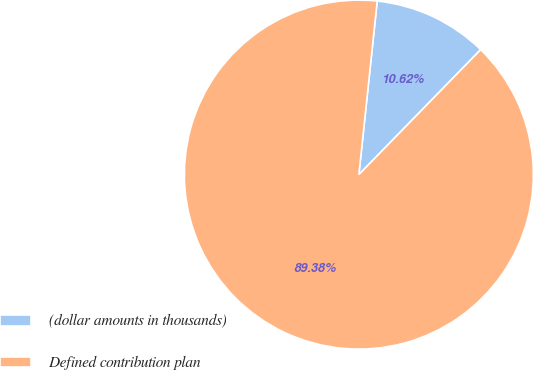<chart> <loc_0><loc_0><loc_500><loc_500><pie_chart><fcel>(dollar amounts in thousands)<fcel>Defined contribution plan<nl><fcel>10.62%<fcel>89.38%<nl></chart> 